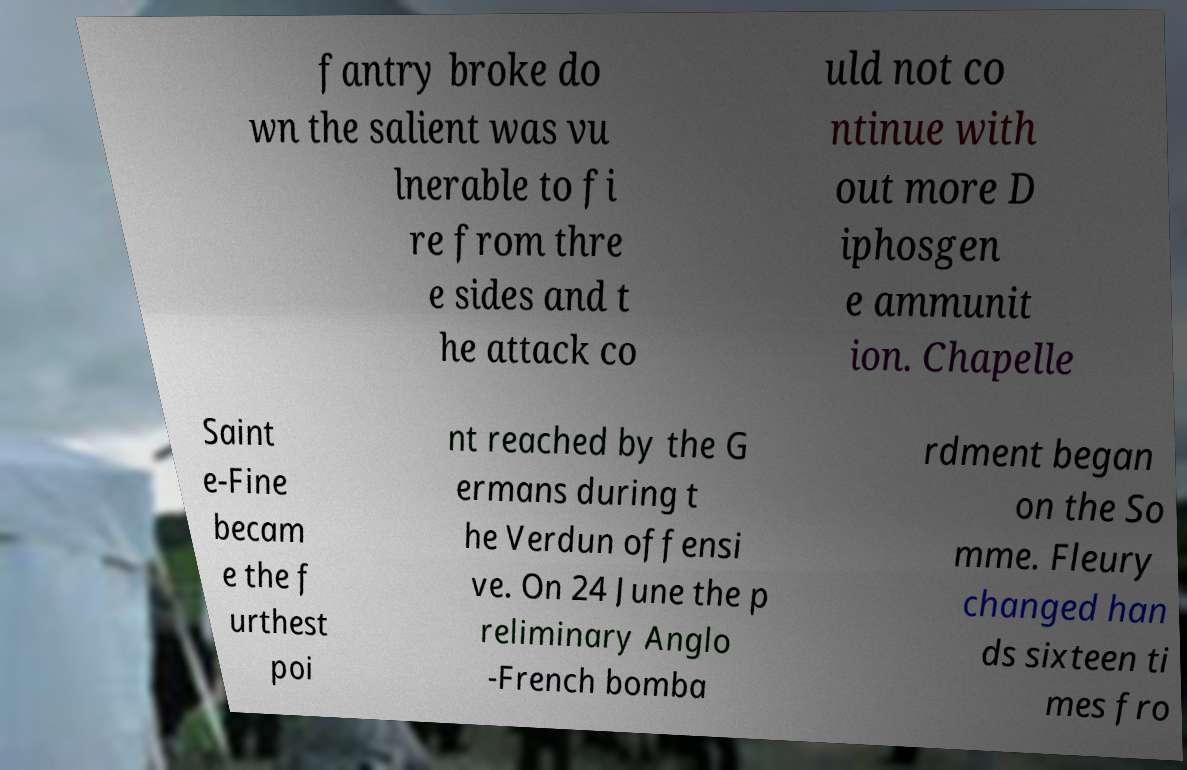Could you extract and type out the text from this image? fantry broke do wn the salient was vu lnerable to fi re from thre e sides and t he attack co uld not co ntinue with out more D iphosgen e ammunit ion. Chapelle Saint e-Fine becam e the f urthest poi nt reached by the G ermans during t he Verdun offensi ve. On 24 June the p reliminary Anglo -French bomba rdment began on the So mme. Fleury changed han ds sixteen ti mes fro 